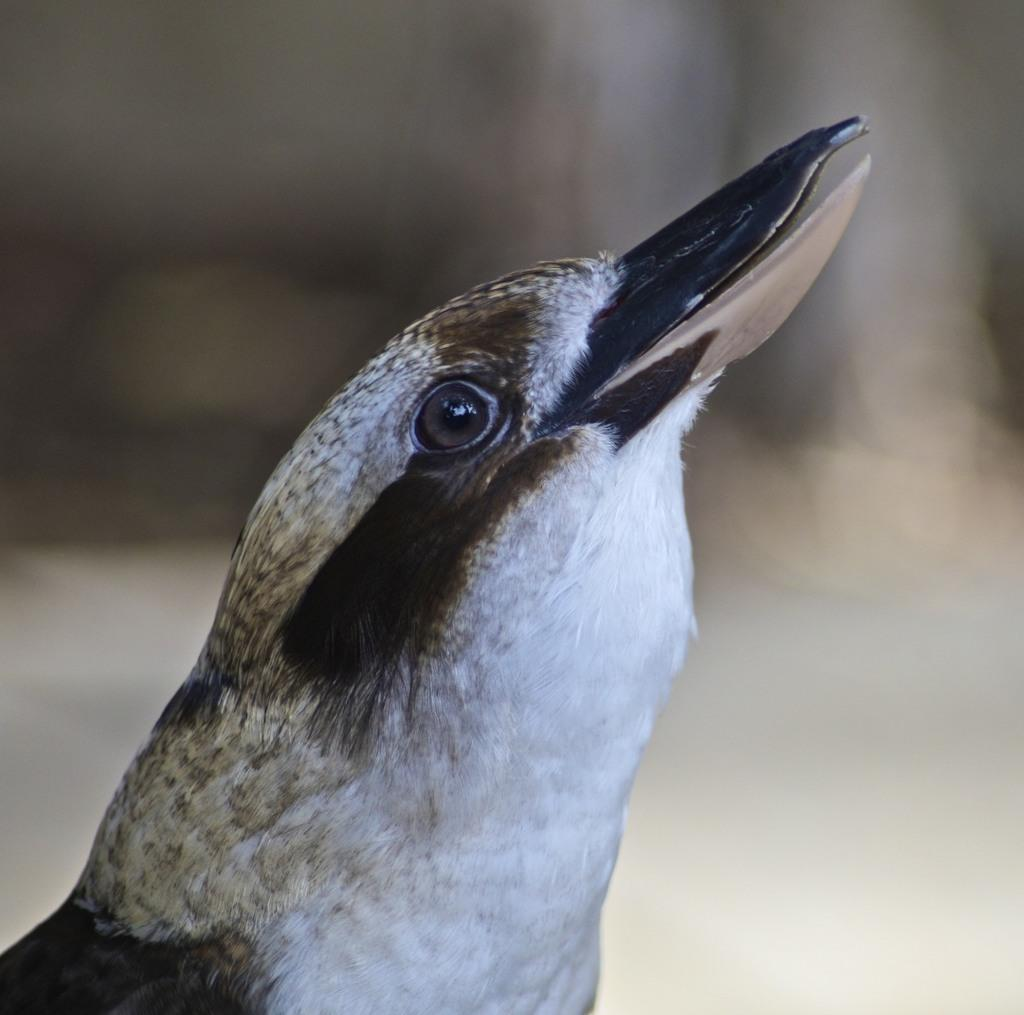What type of animal is in the picture? There is a bird in the picture. Can you describe the bird's beak? The bird has a long beak. What can be said about the background of the image? The backdrop of the image is blurred. How many strangers are present in the image? There are no strangers present in the image; it features a bird with a long beak against a blurred backdrop. 